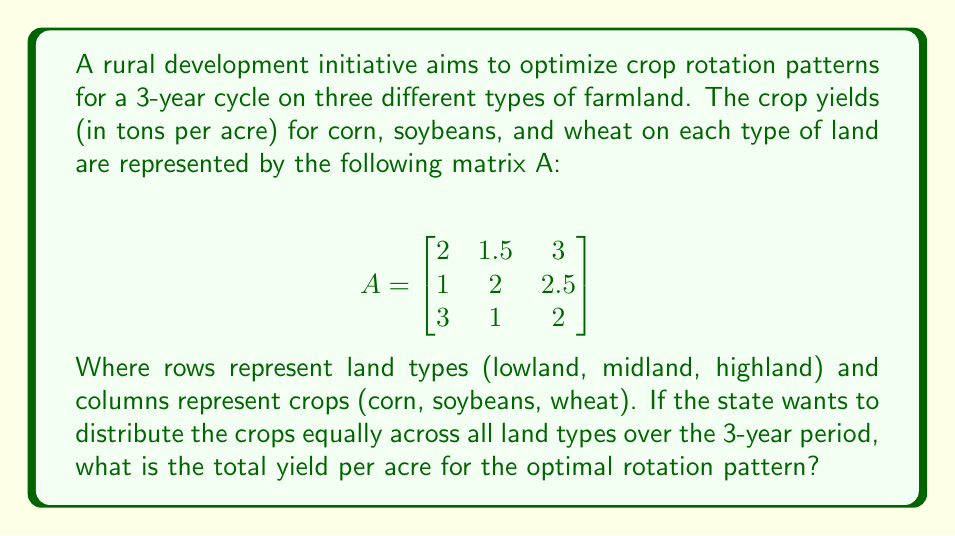Show me your answer to this math problem. To solve this problem, we'll use linear algebra techniques:

1) First, we need to find a rotation matrix that distributes crops equally. This is represented by:

   $$R = \frac{1}{3}\begin{bmatrix}
   1 & 1 & 1 \\
   1 & 1 & 1 \\
   1 & 1 & 1
   \end{bmatrix}$$

2) The optimal yield over 3 years is given by the matrix product AR:

   $$AR = \begin{bmatrix}
   2 & 1.5 & 3 \\
   1 & 2 & 2.5 \\
   3 & 1 & 2
   \end{bmatrix} \cdot \frac{1}{3}\begin{bmatrix}
   1 & 1 & 1 \\
   1 & 1 & 1 \\
   1 & 1 & 1
   \end{bmatrix}$$

3) Calculating this product:

   $$AR = \frac{1}{3}\begin{bmatrix}
   2+1.5+3 & 2+1.5+3 & 2+1.5+3 \\
   1+2+2.5 & 1+2+2.5 & 1+2+2.5 \\
   3+1+2 & 3+1+2 & 3+1+2
   \end{bmatrix}$$

   $$AR = \frac{1}{3}\begin{bmatrix}
   6.5 & 6.5 & 6.5 \\
   5.5 & 5.5 & 5.5 \\
   6 & 6 & 6
   \end{bmatrix}$$

4) The total yield per acre for each land type is the sum of each row:

   Lowland: $\frac{1}{3}(6.5 + 6.5 + 6.5) = 6.5$
   Midland: $\frac{1}{3}(5.5 + 5.5 + 5.5) = 5.5$
   Highland: $\frac{1}{3}(6 + 6 + 6) = 6$

5) The overall total yield per acre is the average of these:

   $\frac{6.5 + 5.5 + 6}{3} = 6$ tons per acre
Answer: 6 tons per acre 